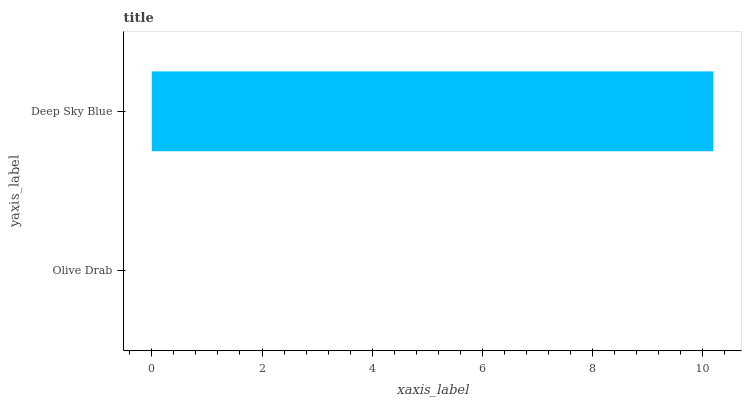Is Olive Drab the minimum?
Answer yes or no. Yes. Is Deep Sky Blue the maximum?
Answer yes or no. Yes. Is Deep Sky Blue the minimum?
Answer yes or no. No. Is Deep Sky Blue greater than Olive Drab?
Answer yes or no. Yes. Is Olive Drab less than Deep Sky Blue?
Answer yes or no. Yes. Is Olive Drab greater than Deep Sky Blue?
Answer yes or no. No. Is Deep Sky Blue less than Olive Drab?
Answer yes or no. No. Is Deep Sky Blue the high median?
Answer yes or no. Yes. Is Olive Drab the low median?
Answer yes or no. Yes. Is Olive Drab the high median?
Answer yes or no. No. Is Deep Sky Blue the low median?
Answer yes or no. No. 